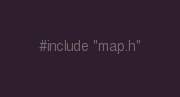<code> <loc_0><loc_0><loc_500><loc_500><_C++_>#include "map.h"</code> 